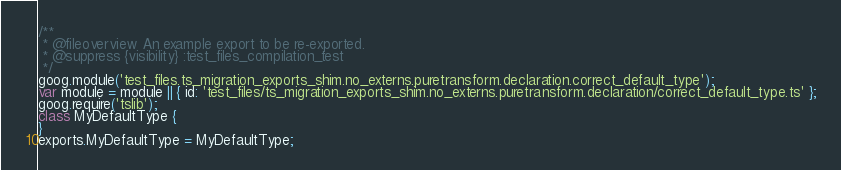Convert code to text. <code><loc_0><loc_0><loc_500><loc_500><_JavaScript_>/**
 * @fileoverview An example export to be re-exported.
 * @suppress {visibility} :test_files_compilation_test
 */
goog.module('test_files.ts_migration_exports_shim.no_externs.puretransform.declaration.correct_default_type');
var module = module || { id: 'test_files/ts_migration_exports_shim.no_externs.puretransform.declaration/correct_default_type.ts' };
goog.require('tslib');
class MyDefaultType {
}
exports.MyDefaultType = MyDefaultType;
</code> 